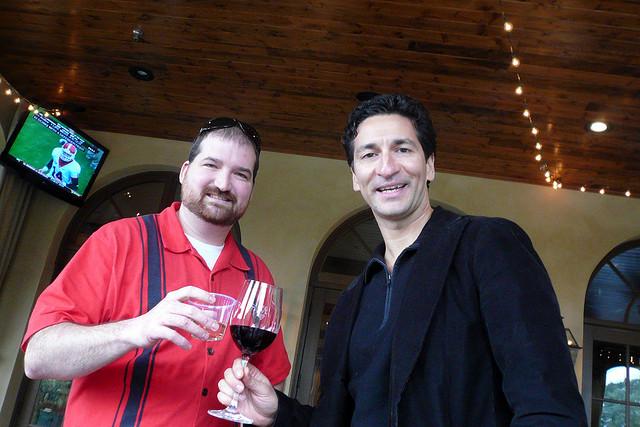What sport is being played on the TV?
Answer briefly. Football. Are these guys happy?
Be succinct. Yes. How many guys are in the photo?
Concise answer only. 2. 